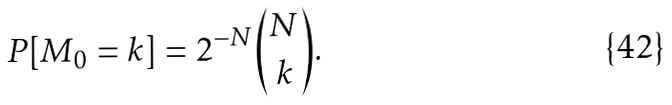<formula> <loc_0><loc_0><loc_500><loc_500>P [ M _ { 0 } = k ] = 2 ^ { - N } \binom { N } { k } .</formula> 